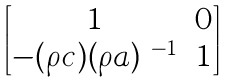<formula> <loc_0><loc_0><loc_500><loc_500>\begin{bmatrix} 1 & 0 \\ - ( \rho c ) ( \rho a ) ^ { \ - 1 } & 1 \\ \end{bmatrix}</formula> 